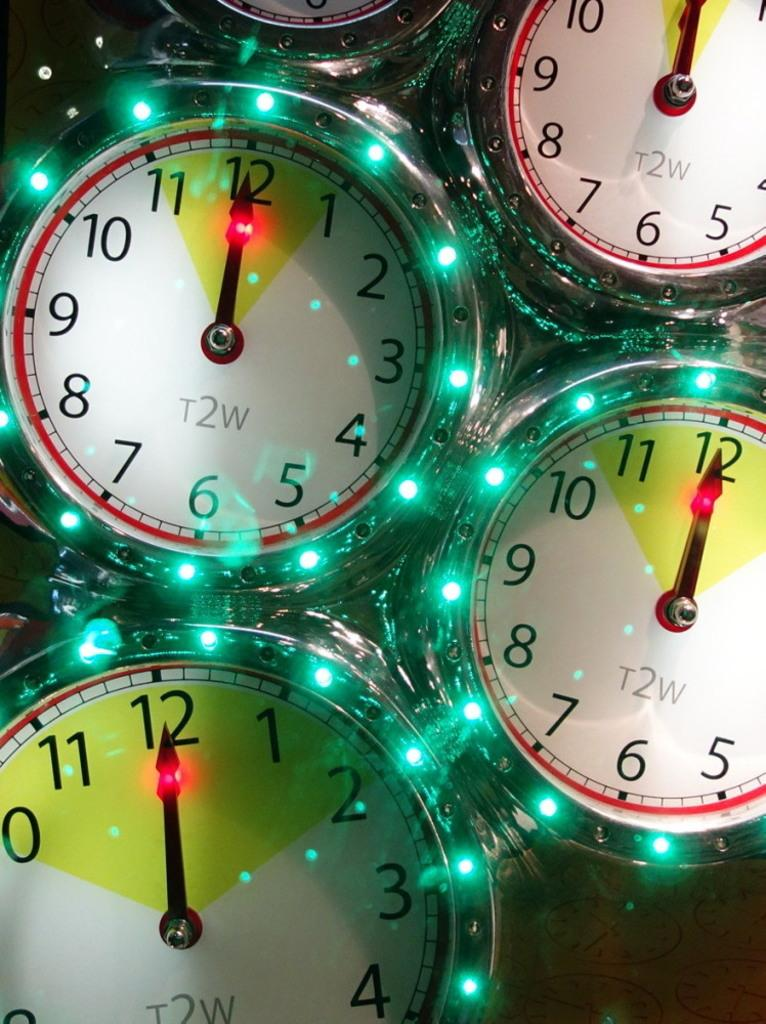<image>
Render a clear and concise summary of the photo. A group of clocks that says T2W all show that it is 12:00. 